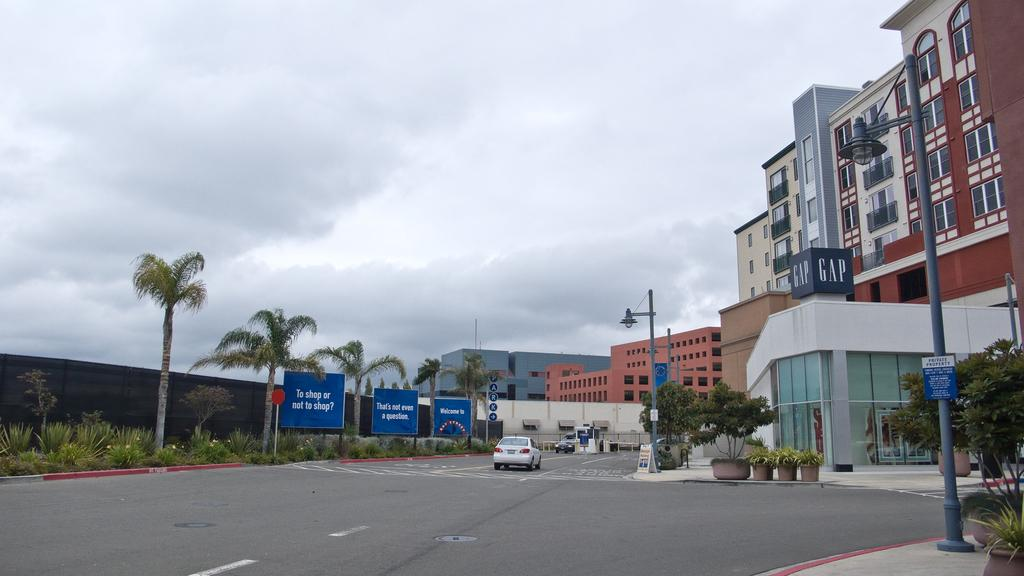What can be seen on the road in the image? There are cars on the road in the image. What objects are present in the image besides the cars? There are boards, plants, trees, poles, a wall, and buildings in the image. What is visible in the background of the image? The sky is visible in the background of the image, with clouds present. What advice is being given by the trees in the image? The trees in the image are not giving any advice, as they are inanimate objects and do not have the ability to communicate or provide advice. 